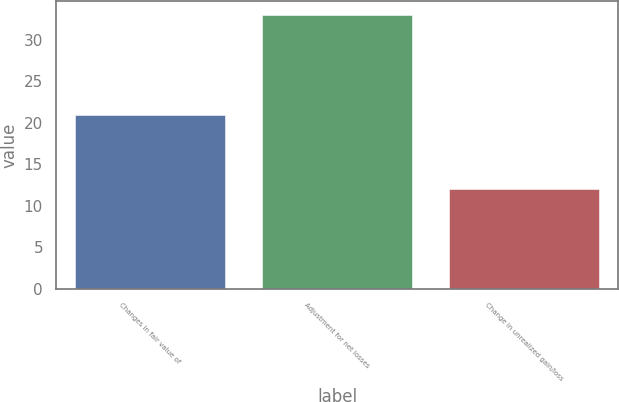<chart> <loc_0><loc_0><loc_500><loc_500><bar_chart><fcel>Changes in fair value of<fcel>Adjustment for net losses<fcel>Change in unrealized gain/loss<nl><fcel>21<fcel>33<fcel>12<nl></chart> 